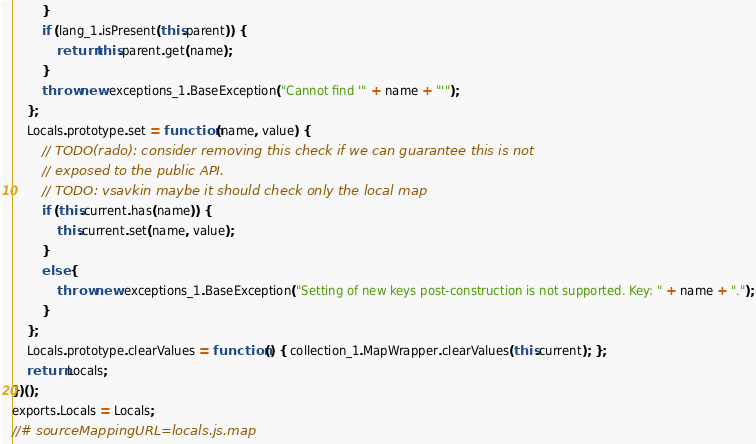<code> <loc_0><loc_0><loc_500><loc_500><_JavaScript_>        }
        if (lang_1.isPresent(this.parent)) {
            return this.parent.get(name);
        }
        throw new exceptions_1.BaseException("Cannot find '" + name + "'");
    };
    Locals.prototype.set = function (name, value) {
        // TODO(rado): consider removing this check if we can guarantee this is not
        // exposed to the public API.
        // TODO: vsavkin maybe it should check only the local map
        if (this.current.has(name)) {
            this.current.set(name, value);
        }
        else {
            throw new exceptions_1.BaseException("Setting of new keys post-construction is not supported. Key: " + name + ".");
        }
    };
    Locals.prototype.clearValues = function () { collection_1.MapWrapper.clearValues(this.current); };
    return Locals;
})();
exports.Locals = Locals;
//# sourceMappingURL=locals.js.map</code> 